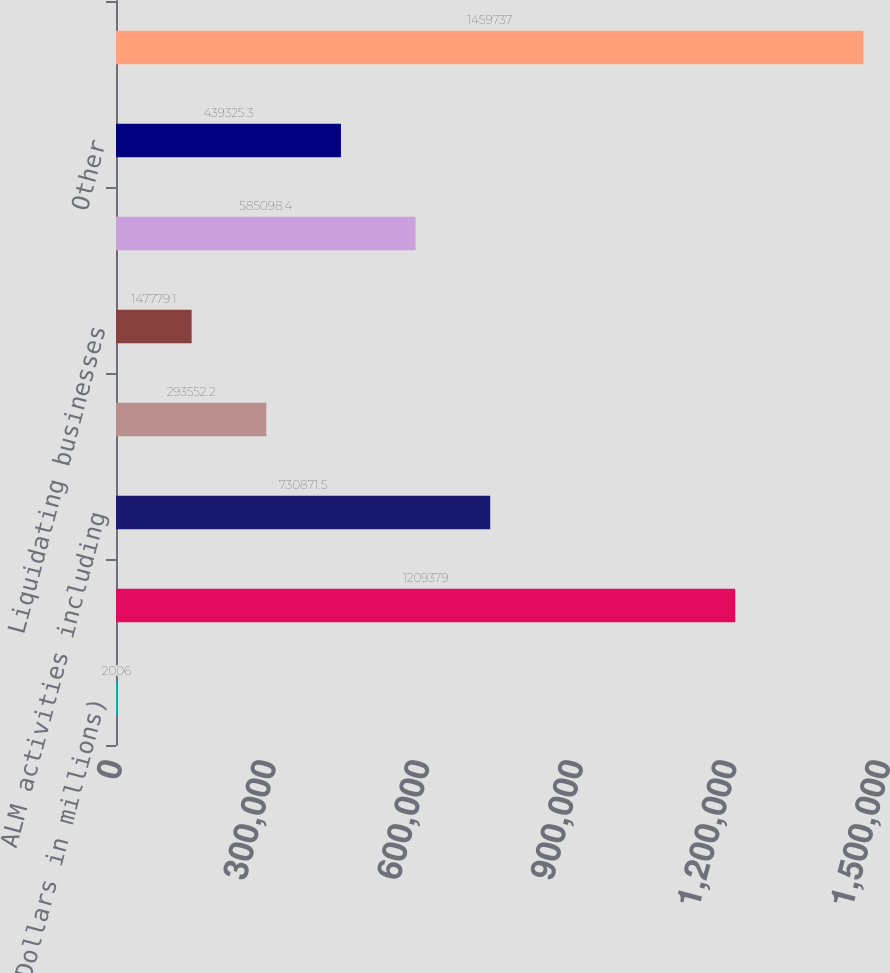Convert chart. <chart><loc_0><loc_0><loc_500><loc_500><bar_chart><fcel>(Dollars in millions)<fcel>Segments' total assets<fcel>ALM activities including<fcel>Equity investments<fcel>Liquidating businesses<fcel>Elimination of segment excess<fcel>Other<fcel>Consolidated total assets<nl><fcel>2006<fcel>1.20938e+06<fcel>730872<fcel>293552<fcel>147779<fcel>585098<fcel>439325<fcel>1.45974e+06<nl></chart> 